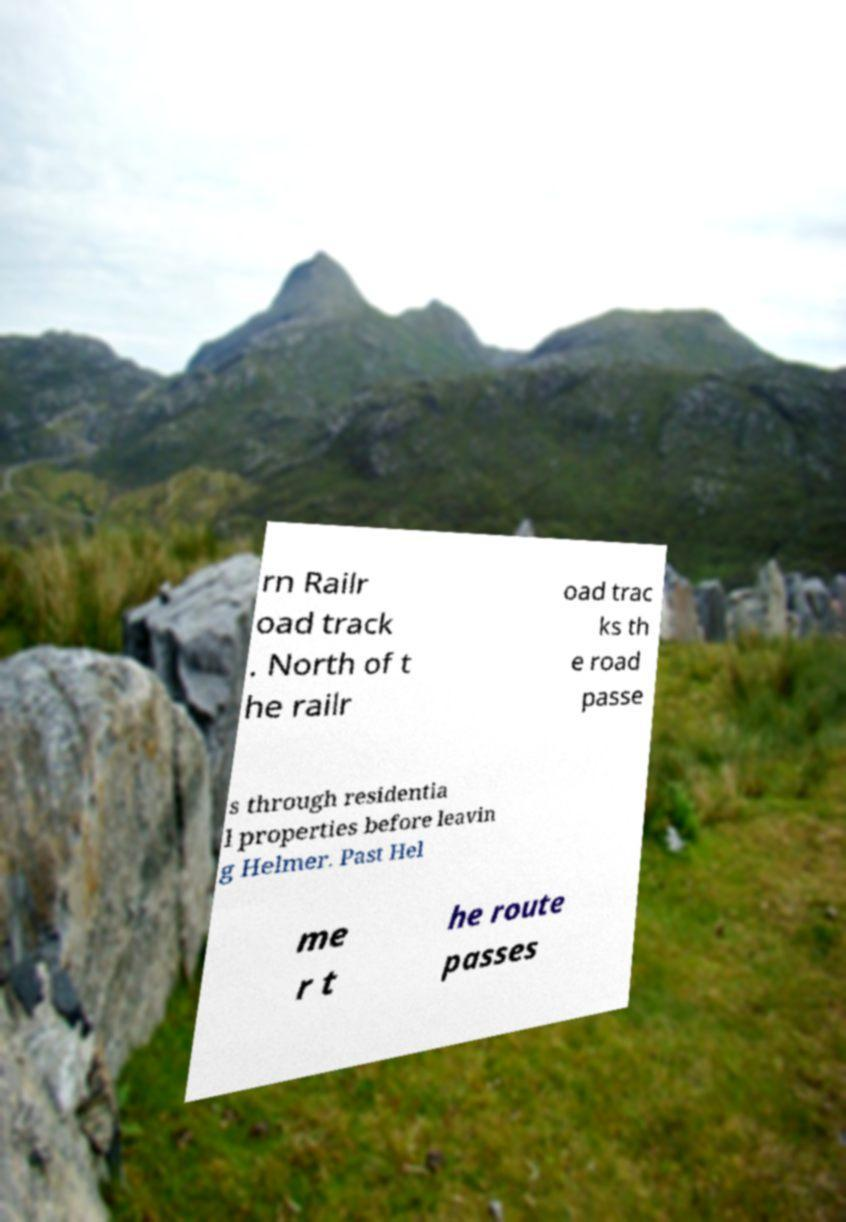Can you read and provide the text displayed in the image?This photo seems to have some interesting text. Can you extract and type it out for me? rn Railr oad track . North of t he railr oad trac ks th e road passe s through residentia l properties before leavin g Helmer. Past Hel me r t he route passes 